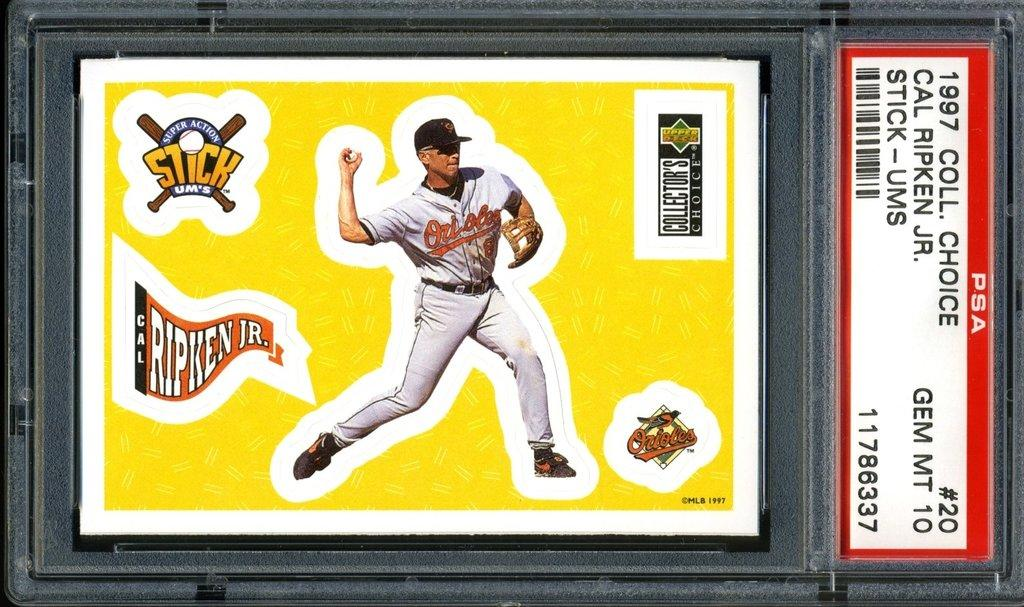<image>
Provide a brief description of the given image. a framed picture that says 'cal ripken jr.' on it 